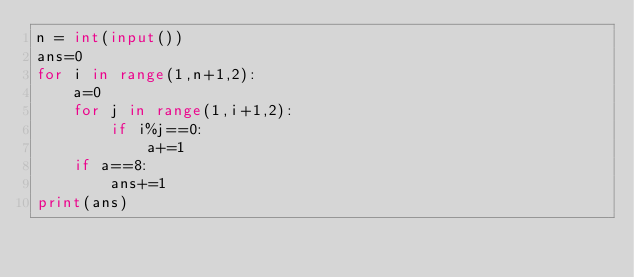<code> <loc_0><loc_0><loc_500><loc_500><_Python_>n = int(input())
ans=0
for i in range(1,n+1,2):
    a=0
    for j in range(1,i+1,2):
        if i%j==0:
            a+=1
    if a==8:
        ans+=1
print(ans)
</code> 